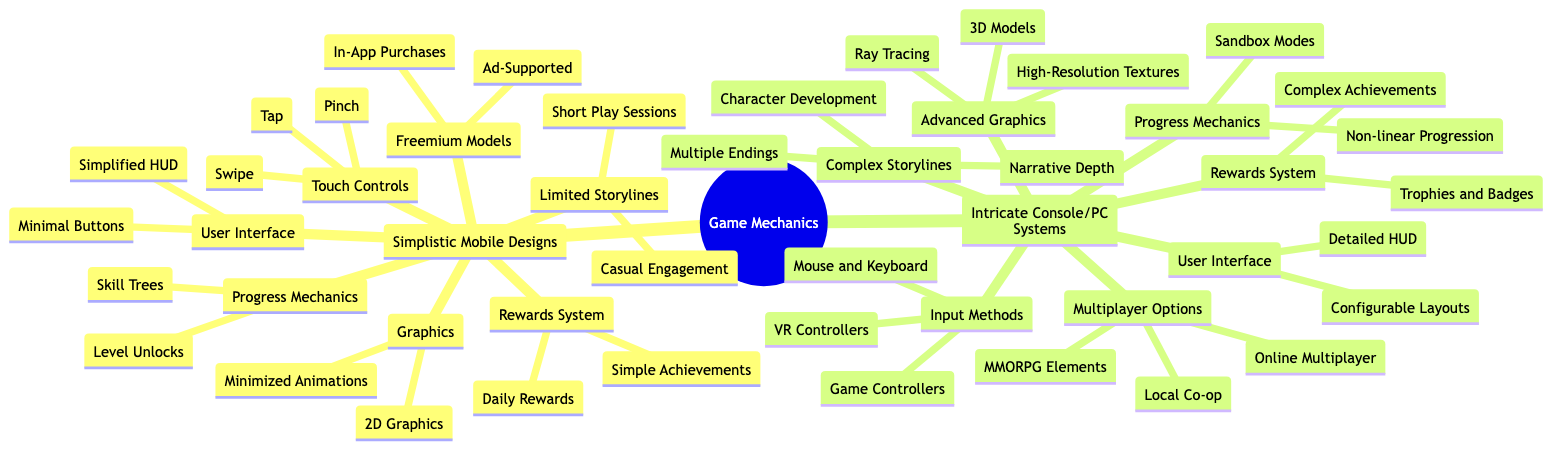What are the input methods for Intricate Console/PC Systems? The diagram lists the input methods under the "Intricate Console/PC Systems" category, which includes "Game Controllers," "Mouse and Keyboard," and "VR Controllers."
Answer: Game Controllers, Mouse and Keyboard, VR Controllers How many types of rewards systems are there in Simplistic Mobile Designs? In the "Simplistic Mobile Designs" section, there are two types of rewards systems listed: "Daily Rewards" and "Simple Achievements."
Answer: 2 What type of graphics is used in Simplistic Mobile Designs? The diagram indicates that the graphics used in "Simplistic Mobile Designs" are "2D Graphics" and "Minimized Animations."
Answer: 2D Graphics, Minimized Animations What is a unique feature of the complex storylines in Intricate Console/PC Systems? The "Complex Storylines" feature multiple components, specifically mentioning "Narrative Depth," "Multiple Endings," and "Character Development," which points to their intricacy.
Answer: Narrative Depth, Multiple Endings, Character Development How do the progress mechanics differ between the two systems? The diagram shows that "Simplistic Mobile Designs" have "Level Unlocks" and "Skill Trees," while "Intricate Console/PC Systems" feature "Sandbox Modes" and "Non-linear Progression," highlighting the differences in complexity and variety of progression mechanics.
Answer: Level Unlocks, Skill Trees vs Sandbox Modes, Non-linear Progression Which system has a multiplayer option? The "Intricate Console/PC Systems" section lists "Online Multiplayer," "Local Co-op," and "MMORPG Elements," indicating that this system has a multiplayer option, whereas there is no mention of multiplayer in the mobile designs section.
Answer: Online Multiplayer, Local Co-op, MMORPG Elements What can be inferred about the user interface in Simplistic Mobile Designs? The user interface in "Simplistic Mobile Designs" is described as having a "Simplified HUD" and "Minimal Buttons," suggesting a focus on ease of use and accessibility over detailed interaction.
Answer: Simplified HUD, Minimal Buttons Which design emphasizes advanced graphics? The "Advanced Graphics" category in "Intricate Console/PC Systems" includes "3D Models," "Ray Tracing," and "High-Resolution Textures," showcasing a commitment to detailed visual fidelity.
Answer: 3D Models, Ray Tracing, High-Resolution Textures 